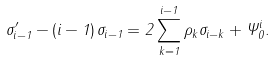Convert formula to latex. <formula><loc_0><loc_0><loc_500><loc_500>\sigma _ { i - 1 } ^ { \prime } - \left ( i - 1 \right ) \sigma _ { i - 1 } = 2 \sum _ { k = 1 } ^ { i - 1 } \rho _ { k } \sigma _ { i - k } + \Psi _ { 0 } ^ { i } .</formula> 